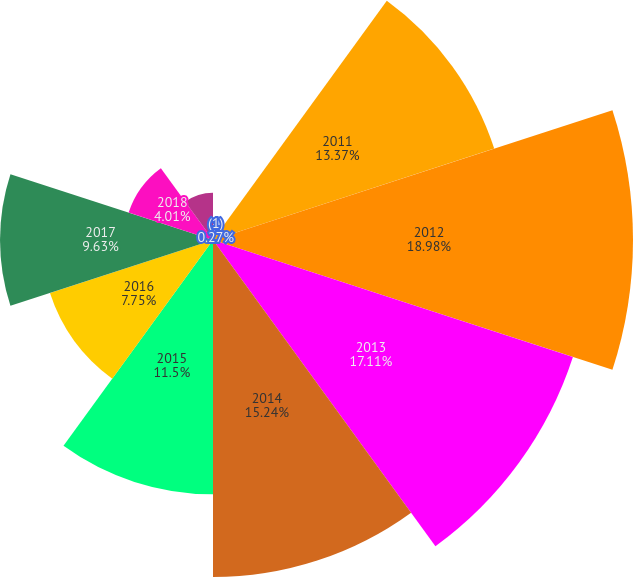<chart> <loc_0><loc_0><loc_500><loc_500><pie_chart><fcel>(1)<fcel>2011<fcel>2012<fcel>2013<fcel>2014<fcel>2015<fcel>2016<fcel>2017<fcel>2018<fcel>2019<nl><fcel>0.27%<fcel>13.37%<fcel>18.99%<fcel>17.11%<fcel>15.24%<fcel>11.5%<fcel>7.75%<fcel>9.63%<fcel>4.01%<fcel>2.14%<nl></chart> 